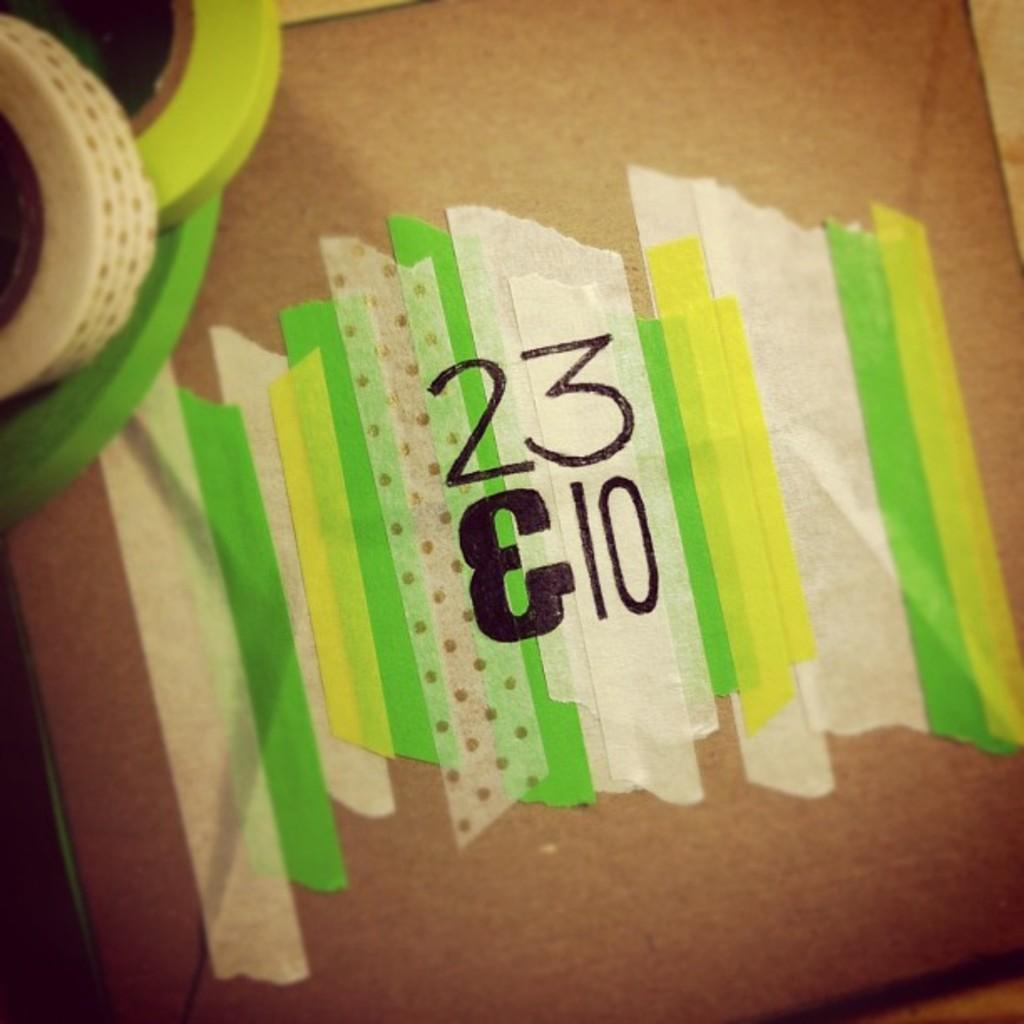What is the main object in the image? There is a board in the image. What is attached to the board? Papers are attached to the board. What can be seen on the papers? There is text written on the papers. Where are the tapes located on the board? The tapes are on the board in the left top area. What invention is being demonstrated in the image? There is no invention being demonstrated in the image; it only shows a board with papers and tapes. Can you tell me how many people are jumping in the image? There are no people jumping in the image; it only shows a board with papers and tapes. 